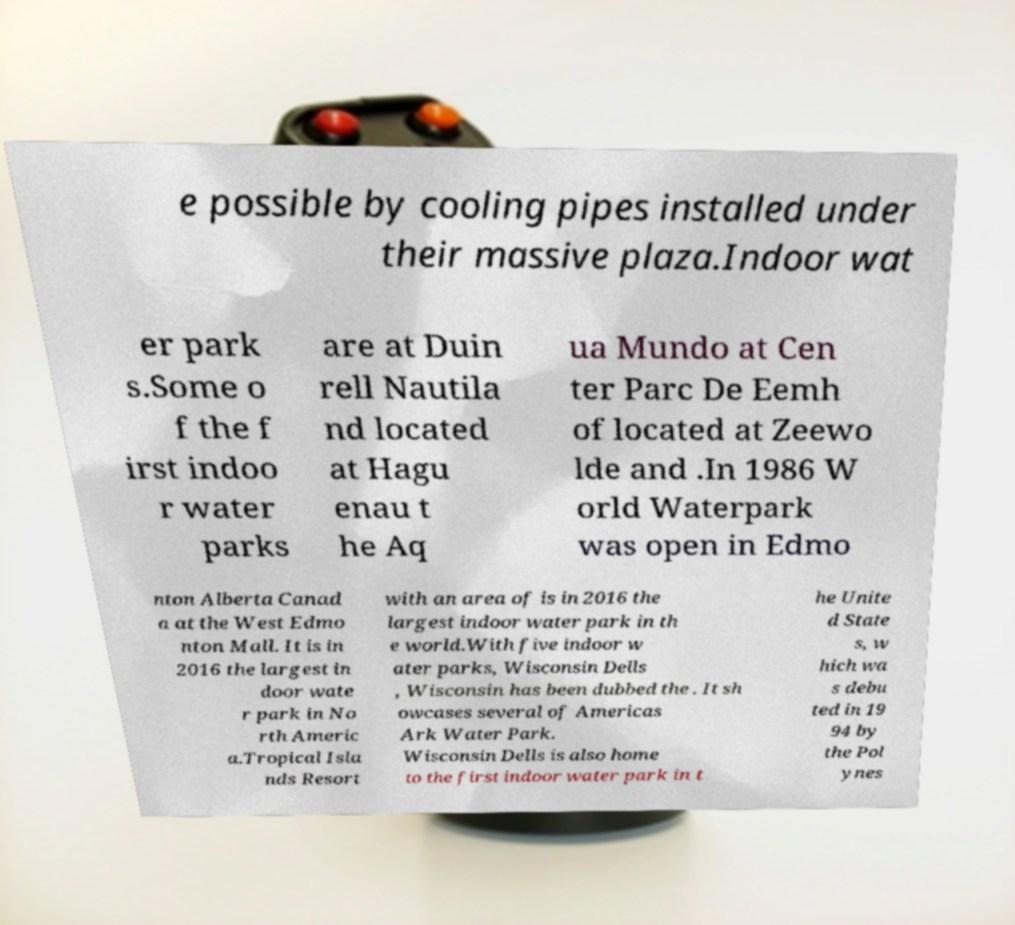Can you read and provide the text displayed in the image?This photo seems to have some interesting text. Can you extract and type it out for me? e possible by cooling pipes installed under their massive plaza.Indoor wat er park s.Some o f the f irst indoo r water parks are at Duin rell Nautila nd located at Hagu enau t he Aq ua Mundo at Cen ter Parc De Eemh of located at Zeewo lde and .In 1986 W orld Waterpark was open in Edmo nton Alberta Canad a at the West Edmo nton Mall. It is in 2016 the largest in door wate r park in No rth Americ a.Tropical Isla nds Resort with an area of is in 2016 the largest indoor water park in th e world.With five indoor w ater parks, Wisconsin Dells , Wisconsin has been dubbed the . It sh owcases several of Americas Ark Water Park. Wisconsin Dells is also home to the first indoor water park in t he Unite d State s, w hich wa s debu ted in 19 94 by the Pol ynes 